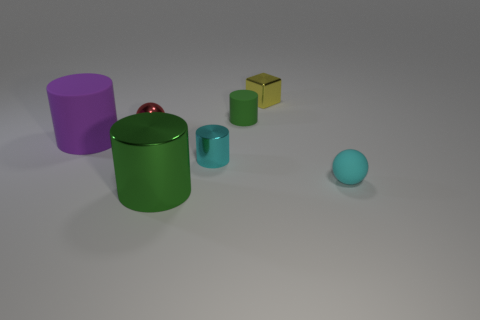Are there an equal number of small blocks that are on the left side of the purple rubber thing and red balls on the left side of the small red metal ball?
Make the answer very short. Yes. What number of other things are made of the same material as the red sphere?
Your answer should be very brief. 3. Is the number of green cylinders behind the purple cylinder the same as the number of small purple matte objects?
Your answer should be very brief. No. There is a red metal object; does it have the same size as the yellow cube to the right of the cyan metal object?
Give a very brief answer. Yes. What is the shape of the tiny cyan object that is behind the cyan sphere?
Give a very brief answer. Cylinder. Are there any other things that are the same shape as the green rubber object?
Make the answer very short. Yes. Are any large shiny cylinders visible?
Offer a very short reply. Yes. Do the object that is on the right side of the tiny yellow cube and the matte thing that is behind the big purple cylinder have the same size?
Offer a terse response. Yes. There is a tiny object that is to the left of the yellow thing and behind the small red object; what is its material?
Provide a short and direct response. Rubber. There is a rubber sphere; what number of small objects are behind it?
Offer a very short reply. 4. 